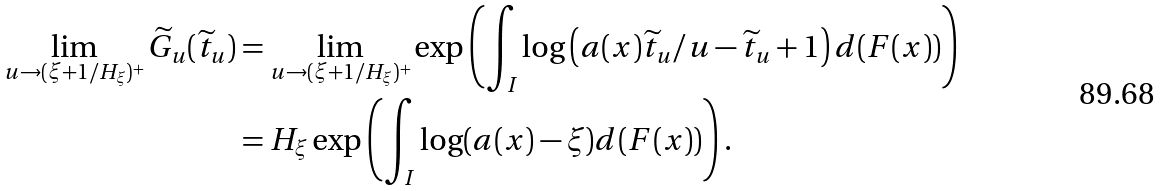Convert formula to latex. <formula><loc_0><loc_0><loc_500><loc_500>\lim _ { u \rightarrow ( \xi + 1 / H _ { \xi } ) ^ { + } } \widetilde { G } _ { u } ( \widetilde { t } _ { u } ) & = \lim _ { u \rightarrow ( \xi + 1 / H _ { \xi } ) ^ { + } } \exp \left ( \int _ { I } \log \left ( a ( x ) \widetilde { t } _ { u } / u - \widetilde { t } _ { u } + 1 \right ) d ( F ( x ) ) \right ) \\ & = H _ { \xi } \exp \left ( \int _ { I } \log ( a ( x ) - \xi ) d ( F ( x ) ) \right ) .</formula> 